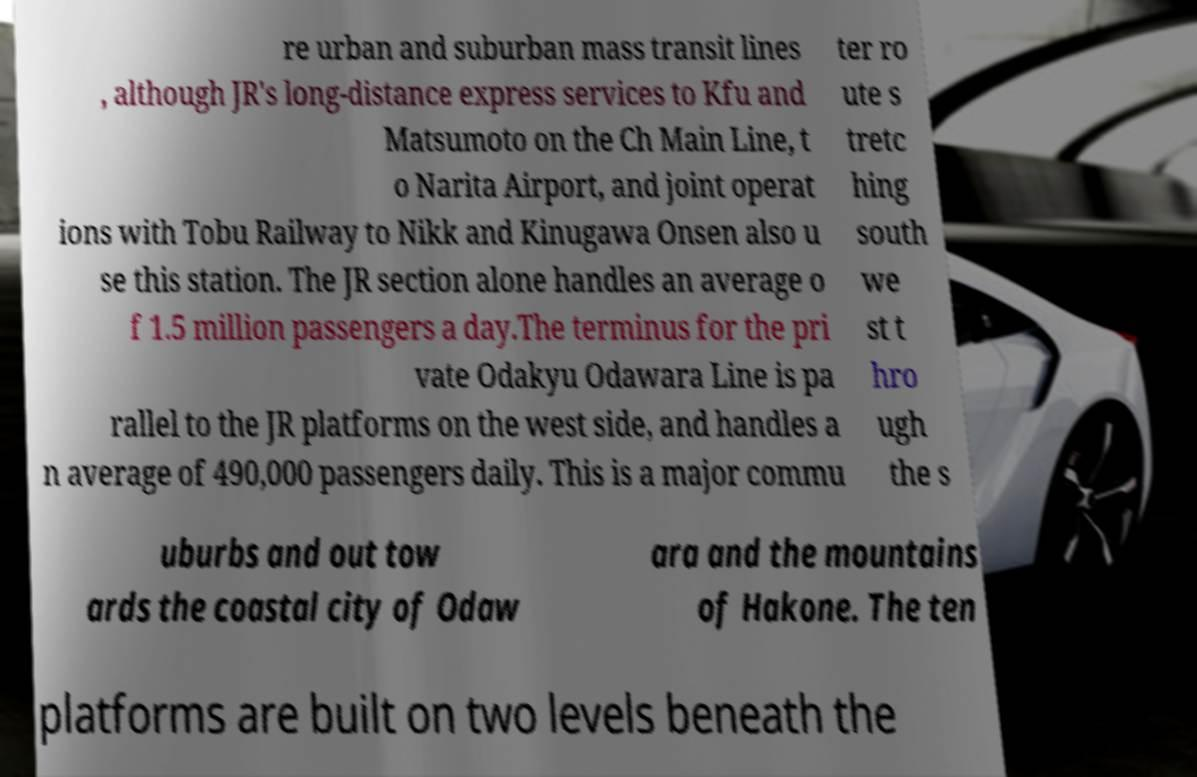There's text embedded in this image that I need extracted. Can you transcribe it verbatim? re urban and suburban mass transit lines , although JR's long-distance express services to Kfu and Matsumoto on the Ch Main Line, t o Narita Airport, and joint operat ions with Tobu Railway to Nikk and Kinugawa Onsen also u se this station. The JR section alone handles an average o f 1.5 million passengers a day.The terminus for the pri vate Odakyu Odawara Line is pa rallel to the JR platforms on the west side, and handles a n average of 490,000 passengers daily. This is a major commu ter ro ute s tretc hing south we st t hro ugh the s uburbs and out tow ards the coastal city of Odaw ara and the mountains of Hakone. The ten platforms are built on two levels beneath the 